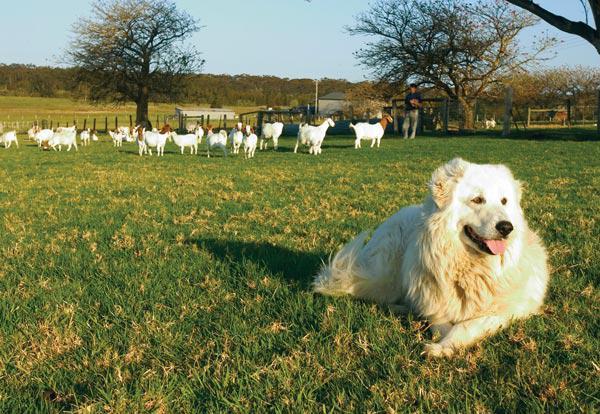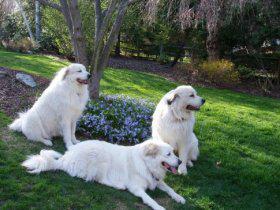The first image is the image on the left, the second image is the image on the right. Examine the images to the left and right. Is the description "A large white dog at an outdoor setting is standing in a pose with a woman wearing jeans, who is leaning back slightly away from the dog." accurate? Answer yes or no. No. The first image is the image on the left, the second image is the image on the right. Considering the images on both sides, is "There are at least two white dogs in the right image." valid? Answer yes or no. Yes. 